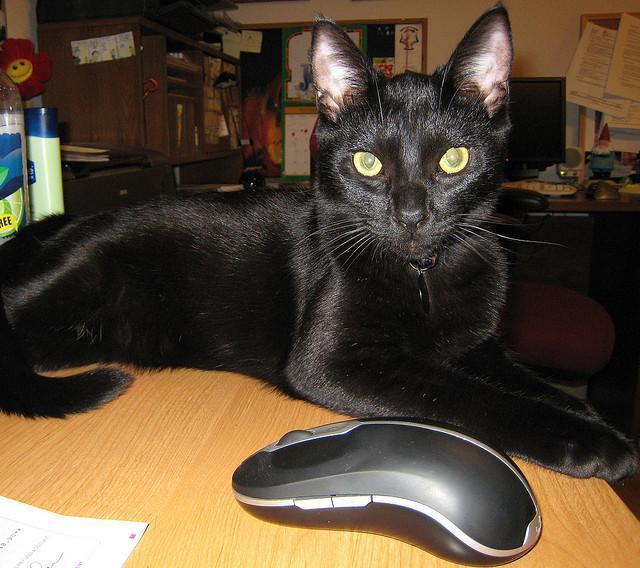How many bottles are visible?
Give a very brief answer. 2. How many chairs can you see?
Give a very brief answer. 1. How many bears in her arms are brown?
Give a very brief answer. 0. 